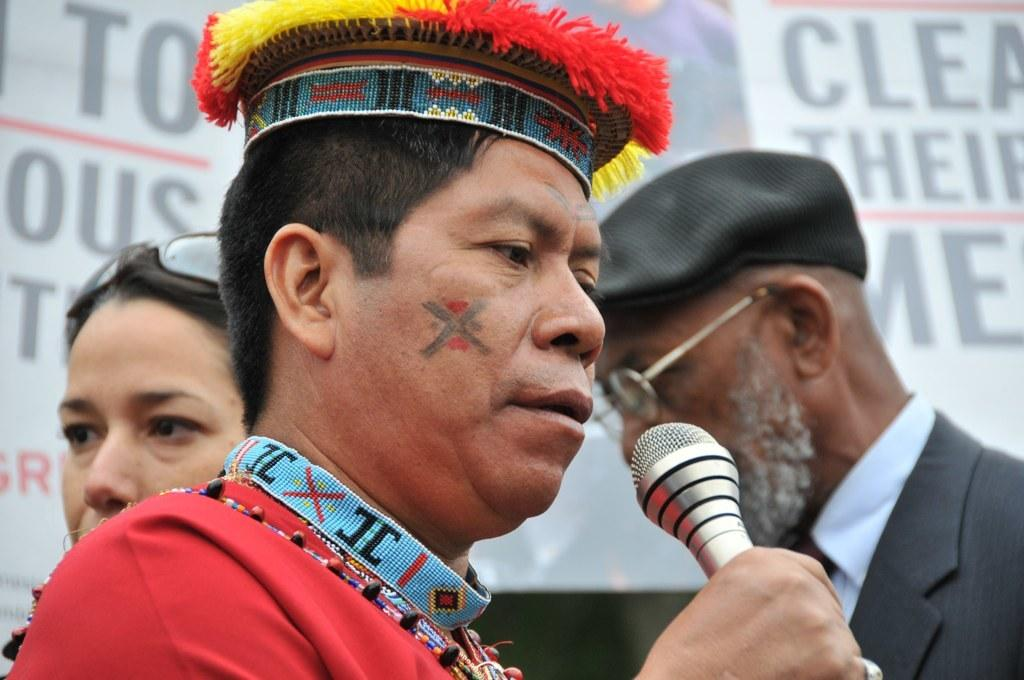What is the person in the image holding in his hand? The person in the image is holding a mic in his hand. Can you describe the people standing at the back in the image? There are multiple people standing at the back in the image. What type of playground equipment can be seen in the image? There is no playground equipment present in the image. What kind of steel is being used to construct the stage in the image? There is no stage or steel mentioned in the image. 